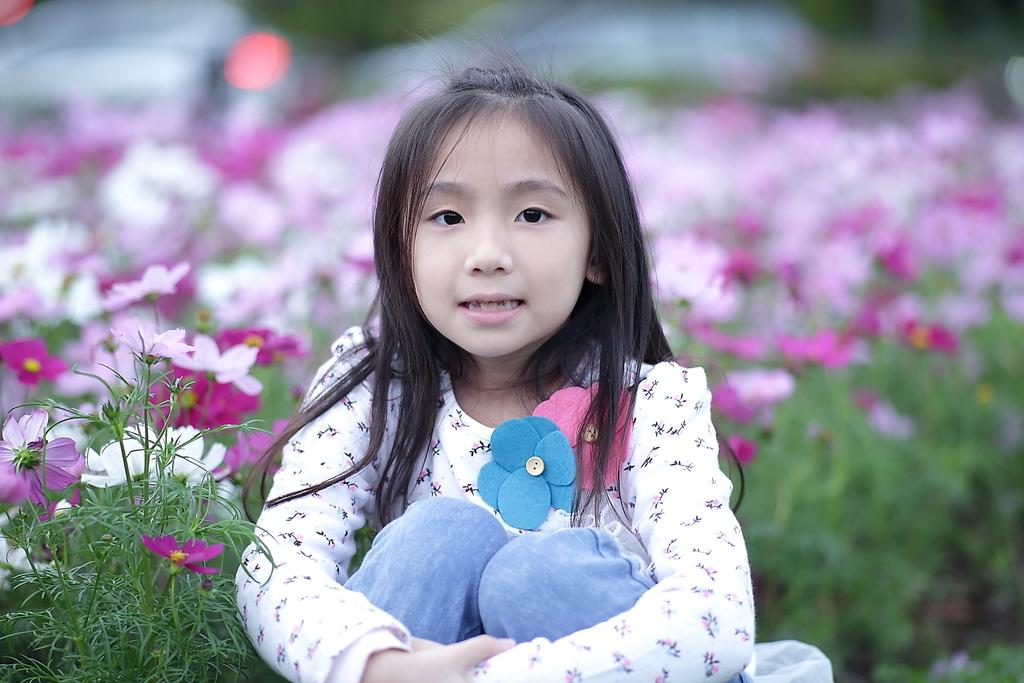What is the main subject in the center of the image? There is a girl sitting in the center of the image. What type of natural elements can be seen in the image? There are plants and flowers in the image. What is the rate of the girl's laughter in the image? There is no indication of the girl's laughter or any rate associated with it in the image. Is there any snow visible in the image? There is no snow present in the image. 